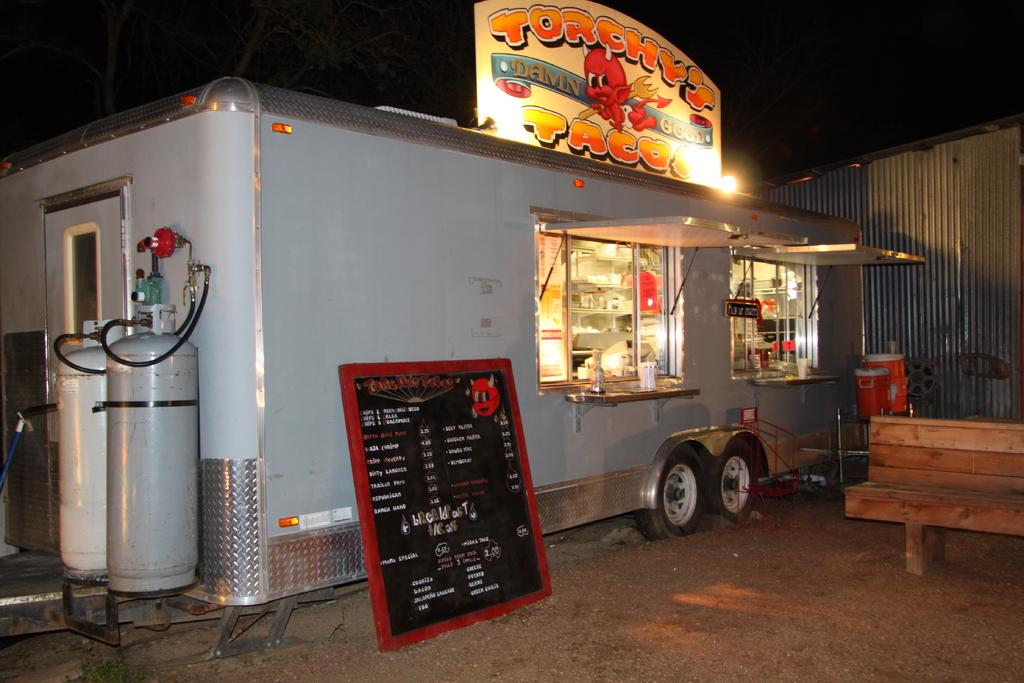What type of vehicle is present in the image? There is a food truck in the image. What can be seen near the food truck? There is a menu board in the image. What type of seating is available in the image? There is a bench in the image. What type of bird can be seen perched on the menu board in the image? There is no bird present on the menu board in the image. What type of vein is visible on the skin of the person in the image? There is no person present in the image, and therefore no visible veins or skin. 